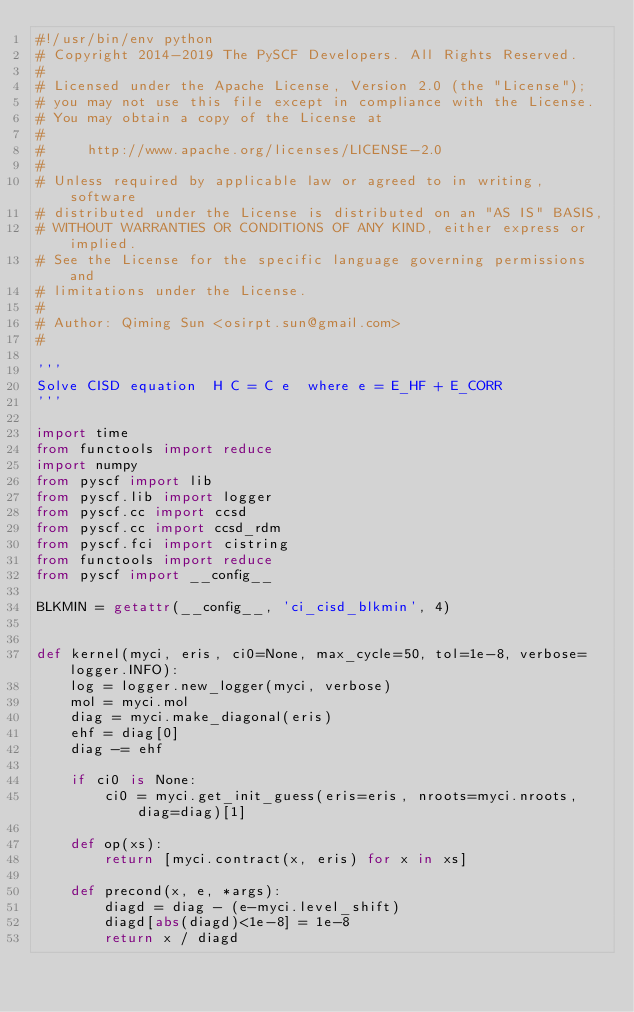Convert code to text. <code><loc_0><loc_0><loc_500><loc_500><_Python_>#!/usr/bin/env python
# Copyright 2014-2019 The PySCF Developers. All Rights Reserved.
#
# Licensed under the Apache License, Version 2.0 (the "License");
# you may not use this file except in compliance with the License.
# You may obtain a copy of the License at
#
#     http://www.apache.org/licenses/LICENSE-2.0
#
# Unless required by applicable law or agreed to in writing, software
# distributed under the License is distributed on an "AS IS" BASIS,
# WITHOUT WARRANTIES OR CONDITIONS OF ANY KIND, either express or implied.
# See the License for the specific language governing permissions and
# limitations under the License.
#
# Author: Qiming Sun <osirpt.sun@gmail.com>
#

'''
Solve CISD equation  H C = C e  where e = E_HF + E_CORR
'''

import time
from functools import reduce
import numpy
from pyscf import lib
from pyscf.lib import logger
from pyscf.cc import ccsd
from pyscf.cc import ccsd_rdm
from pyscf.fci import cistring
from functools import reduce
from pyscf import __config__

BLKMIN = getattr(__config__, 'ci_cisd_blkmin', 4)


def kernel(myci, eris, ci0=None, max_cycle=50, tol=1e-8, verbose=logger.INFO):
    log = logger.new_logger(myci, verbose)
    mol = myci.mol
    diag = myci.make_diagonal(eris)
    ehf = diag[0]
    diag -= ehf

    if ci0 is None:
        ci0 = myci.get_init_guess(eris=eris, nroots=myci.nroots, diag=diag)[1]

    def op(xs):
        return [myci.contract(x, eris) for x in xs]

    def precond(x, e, *args):
        diagd = diag - (e-myci.level_shift)
        diagd[abs(diagd)<1e-8] = 1e-8
        return x / diagd
</code> 